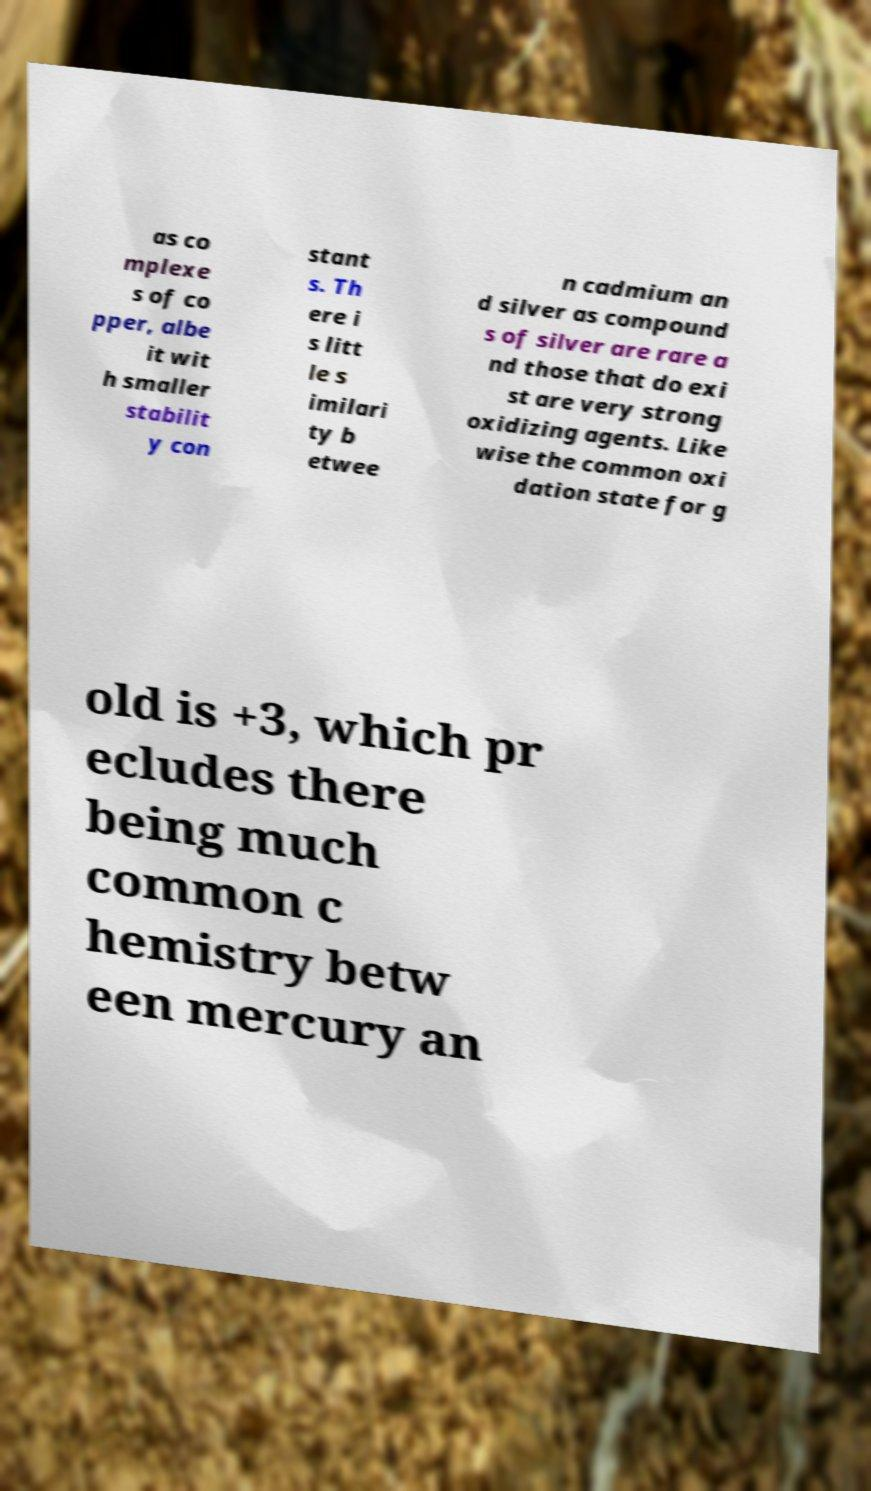Could you extract and type out the text from this image? as co mplexe s of co pper, albe it wit h smaller stabilit y con stant s. Th ere i s litt le s imilari ty b etwee n cadmium an d silver as compound s of silver are rare a nd those that do exi st are very strong oxidizing agents. Like wise the common oxi dation state for g old is +3, which pr ecludes there being much common c hemistry betw een mercury an 